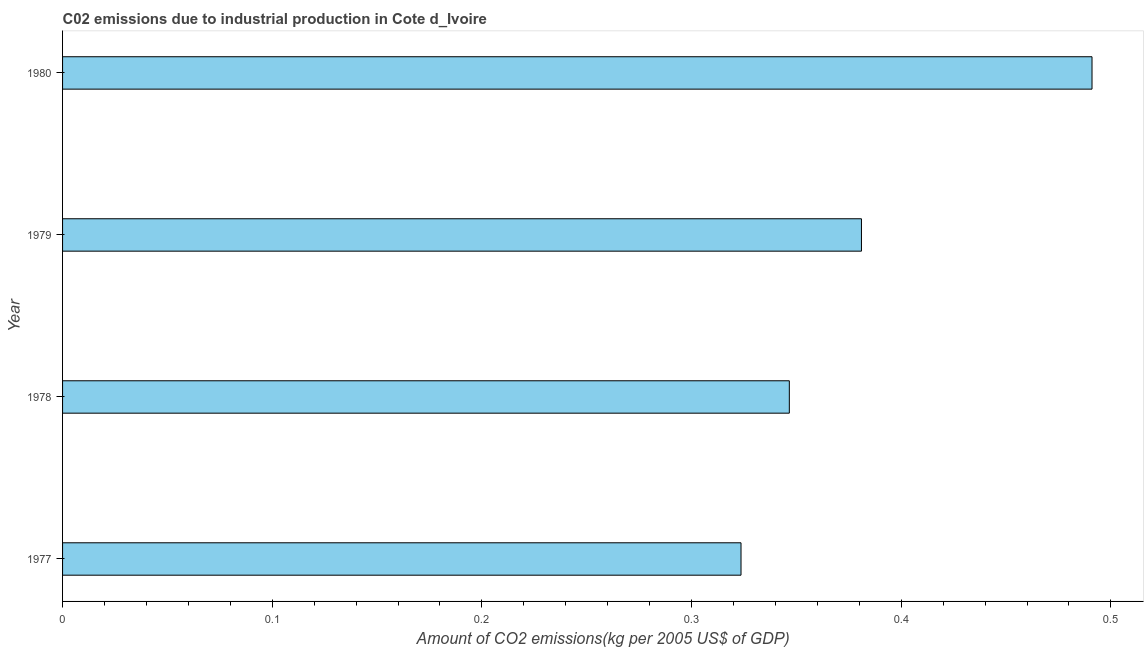Does the graph contain any zero values?
Provide a short and direct response. No. Does the graph contain grids?
Provide a short and direct response. No. What is the title of the graph?
Ensure brevity in your answer.  C02 emissions due to industrial production in Cote d_Ivoire. What is the label or title of the X-axis?
Keep it short and to the point. Amount of CO2 emissions(kg per 2005 US$ of GDP). What is the label or title of the Y-axis?
Make the answer very short. Year. What is the amount of co2 emissions in 1980?
Keep it short and to the point. 0.49. Across all years, what is the maximum amount of co2 emissions?
Keep it short and to the point. 0.49. Across all years, what is the minimum amount of co2 emissions?
Ensure brevity in your answer.  0.32. In which year was the amount of co2 emissions maximum?
Your answer should be compact. 1980. What is the sum of the amount of co2 emissions?
Provide a succinct answer. 1.54. What is the difference between the amount of co2 emissions in 1977 and 1978?
Keep it short and to the point. -0.02. What is the average amount of co2 emissions per year?
Offer a very short reply. 0.39. What is the median amount of co2 emissions?
Make the answer very short. 0.36. In how many years, is the amount of co2 emissions greater than 0.22 kg per 2005 US$ of GDP?
Your answer should be compact. 4. What is the ratio of the amount of co2 emissions in 1979 to that in 1980?
Provide a short and direct response. 0.78. What is the difference between the highest and the second highest amount of co2 emissions?
Ensure brevity in your answer.  0.11. What is the difference between the highest and the lowest amount of co2 emissions?
Provide a short and direct response. 0.17. How many bars are there?
Offer a very short reply. 4. Are all the bars in the graph horizontal?
Offer a very short reply. Yes. How many years are there in the graph?
Your answer should be very brief. 4. What is the difference between two consecutive major ticks on the X-axis?
Provide a short and direct response. 0.1. Are the values on the major ticks of X-axis written in scientific E-notation?
Ensure brevity in your answer.  No. What is the Amount of CO2 emissions(kg per 2005 US$ of GDP) in 1977?
Your answer should be compact. 0.32. What is the Amount of CO2 emissions(kg per 2005 US$ of GDP) in 1978?
Make the answer very short. 0.35. What is the Amount of CO2 emissions(kg per 2005 US$ of GDP) of 1979?
Give a very brief answer. 0.38. What is the Amount of CO2 emissions(kg per 2005 US$ of GDP) in 1980?
Make the answer very short. 0.49. What is the difference between the Amount of CO2 emissions(kg per 2005 US$ of GDP) in 1977 and 1978?
Ensure brevity in your answer.  -0.02. What is the difference between the Amount of CO2 emissions(kg per 2005 US$ of GDP) in 1977 and 1979?
Offer a terse response. -0.06. What is the difference between the Amount of CO2 emissions(kg per 2005 US$ of GDP) in 1977 and 1980?
Your response must be concise. -0.17. What is the difference between the Amount of CO2 emissions(kg per 2005 US$ of GDP) in 1978 and 1979?
Offer a terse response. -0.03. What is the difference between the Amount of CO2 emissions(kg per 2005 US$ of GDP) in 1978 and 1980?
Give a very brief answer. -0.14. What is the difference between the Amount of CO2 emissions(kg per 2005 US$ of GDP) in 1979 and 1980?
Your answer should be very brief. -0.11. What is the ratio of the Amount of CO2 emissions(kg per 2005 US$ of GDP) in 1977 to that in 1978?
Provide a short and direct response. 0.93. What is the ratio of the Amount of CO2 emissions(kg per 2005 US$ of GDP) in 1977 to that in 1979?
Give a very brief answer. 0.85. What is the ratio of the Amount of CO2 emissions(kg per 2005 US$ of GDP) in 1977 to that in 1980?
Your answer should be compact. 0.66. What is the ratio of the Amount of CO2 emissions(kg per 2005 US$ of GDP) in 1978 to that in 1979?
Provide a succinct answer. 0.91. What is the ratio of the Amount of CO2 emissions(kg per 2005 US$ of GDP) in 1978 to that in 1980?
Your answer should be very brief. 0.71. What is the ratio of the Amount of CO2 emissions(kg per 2005 US$ of GDP) in 1979 to that in 1980?
Offer a terse response. 0.78. 